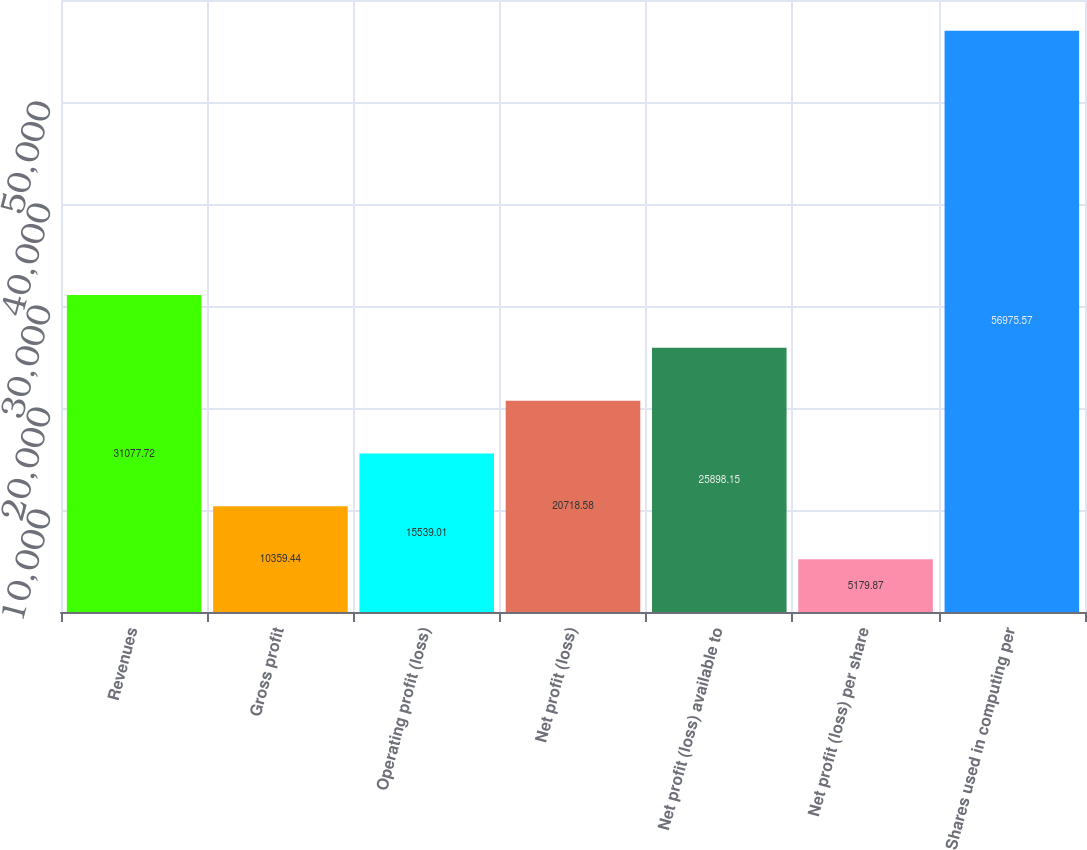Convert chart. <chart><loc_0><loc_0><loc_500><loc_500><bar_chart><fcel>Revenues<fcel>Gross profit<fcel>Operating profit (loss)<fcel>Net profit (loss)<fcel>Net profit (loss) available to<fcel>Net profit (loss) per share<fcel>Shares used in computing per<nl><fcel>31077.7<fcel>10359.4<fcel>15539<fcel>20718.6<fcel>25898.2<fcel>5179.87<fcel>56975.6<nl></chart> 